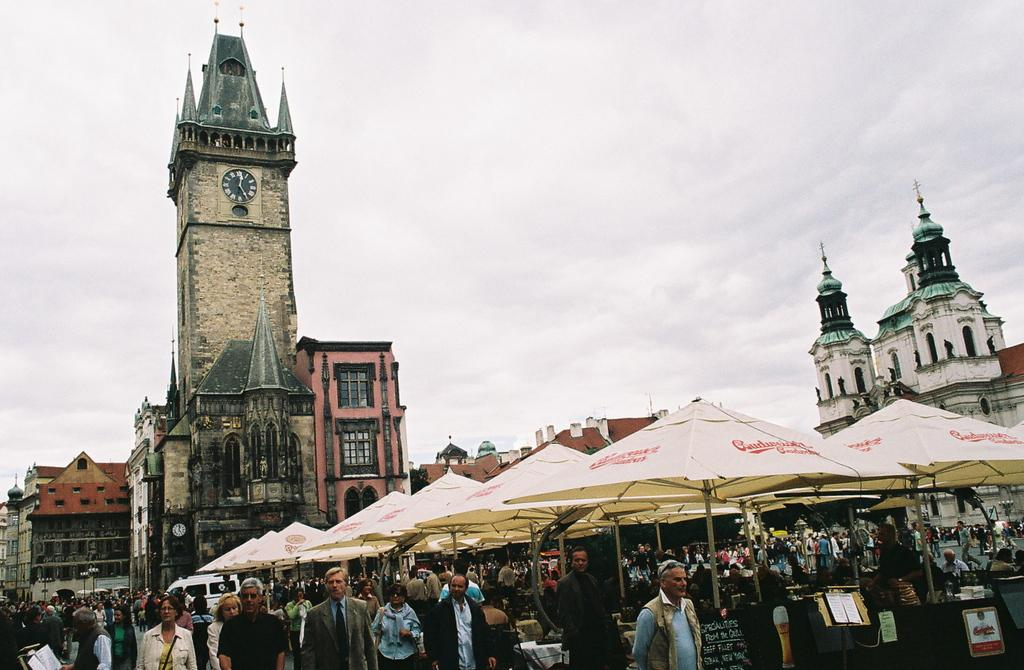What is the main subject of the image? The main subject of the image is a group of people standing. What objects are visible in the image that might be used for protection from the elements? There are umbrellas in the image. What type of structures can be seen in the background of the image? There are buildings with windows in the image. What time-related object is present in the image? There is a clock in the image. What can be seen in the sky in the background of the image? The sky with clouds is visible in the background of the image. What type of leather is visible on the legs of the people in the image? There is no leather visible on the legs of the people in the image. What is the backdrop of the image made of? The backdrop of the image is not mentioned, but it is likely made of a solid material or a natural background. 